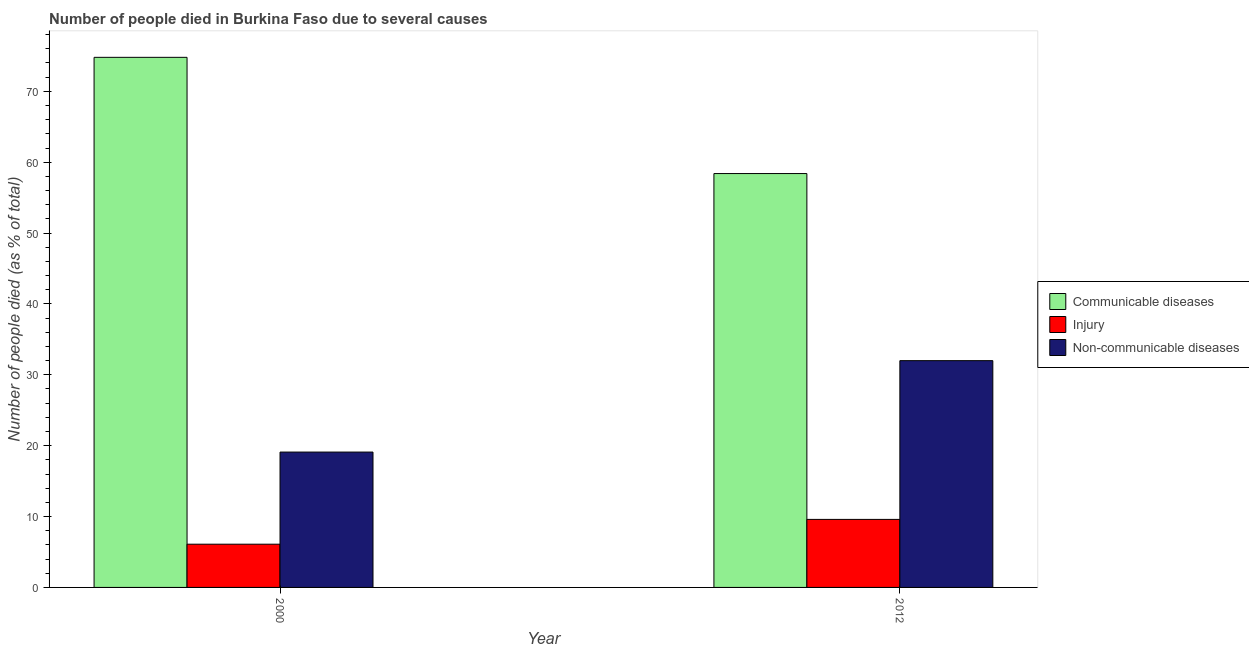Are the number of bars per tick equal to the number of legend labels?
Provide a succinct answer. Yes. Are the number of bars on each tick of the X-axis equal?
Give a very brief answer. Yes. How many bars are there on the 2nd tick from the right?
Ensure brevity in your answer.  3. What is the number of people who died of communicable diseases in 2012?
Keep it short and to the point. 58.4. Across all years, what is the minimum number of people who died of injury?
Give a very brief answer. 6.1. In which year was the number of people who died of communicable diseases maximum?
Provide a short and direct response. 2000. What is the total number of people who died of communicable diseases in the graph?
Keep it short and to the point. 133.2. What is the difference between the number of people who died of injury in 2000 and that in 2012?
Make the answer very short. -3.5. What is the average number of people who died of injury per year?
Offer a terse response. 7.85. In how many years, is the number of people who dies of non-communicable diseases greater than 2 %?
Offer a terse response. 2. What is the ratio of the number of people who dies of non-communicable diseases in 2000 to that in 2012?
Your answer should be very brief. 0.6. Is the number of people who died of communicable diseases in 2000 less than that in 2012?
Make the answer very short. No. What does the 3rd bar from the left in 2000 represents?
Keep it short and to the point. Non-communicable diseases. What does the 3rd bar from the right in 2000 represents?
Make the answer very short. Communicable diseases. Are all the bars in the graph horizontal?
Make the answer very short. No. How many years are there in the graph?
Your response must be concise. 2. Does the graph contain any zero values?
Keep it short and to the point. No. How many legend labels are there?
Provide a short and direct response. 3. How are the legend labels stacked?
Ensure brevity in your answer.  Vertical. What is the title of the graph?
Offer a very short reply. Number of people died in Burkina Faso due to several causes. What is the label or title of the X-axis?
Ensure brevity in your answer.  Year. What is the label or title of the Y-axis?
Your answer should be compact. Number of people died (as % of total). What is the Number of people died (as % of total) of Communicable diseases in 2000?
Offer a terse response. 74.8. What is the Number of people died (as % of total) in Non-communicable diseases in 2000?
Provide a succinct answer. 19.1. What is the Number of people died (as % of total) in Communicable diseases in 2012?
Offer a very short reply. 58.4. What is the Number of people died (as % of total) in Non-communicable diseases in 2012?
Offer a very short reply. 32. Across all years, what is the maximum Number of people died (as % of total) in Communicable diseases?
Give a very brief answer. 74.8. Across all years, what is the minimum Number of people died (as % of total) of Communicable diseases?
Offer a terse response. 58.4. Across all years, what is the minimum Number of people died (as % of total) of Injury?
Ensure brevity in your answer.  6.1. Across all years, what is the minimum Number of people died (as % of total) in Non-communicable diseases?
Provide a short and direct response. 19.1. What is the total Number of people died (as % of total) in Communicable diseases in the graph?
Keep it short and to the point. 133.2. What is the total Number of people died (as % of total) of Injury in the graph?
Offer a very short reply. 15.7. What is the total Number of people died (as % of total) of Non-communicable diseases in the graph?
Your answer should be very brief. 51.1. What is the difference between the Number of people died (as % of total) of Non-communicable diseases in 2000 and that in 2012?
Ensure brevity in your answer.  -12.9. What is the difference between the Number of people died (as % of total) in Communicable diseases in 2000 and the Number of people died (as % of total) in Injury in 2012?
Provide a short and direct response. 65.2. What is the difference between the Number of people died (as % of total) of Communicable diseases in 2000 and the Number of people died (as % of total) of Non-communicable diseases in 2012?
Your answer should be very brief. 42.8. What is the difference between the Number of people died (as % of total) in Injury in 2000 and the Number of people died (as % of total) in Non-communicable diseases in 2012?
Offer a very short reply. -25.9. What is the average Number of people died (as % of total) in Communicable diseases per year?
Your answer should be very brief. 66.6. What is the average Number of people died (as % of total) in Injury per year?
Make the answer very short. 7.85. What is the average Number of people died (as % of total) of Non-communicable diseases per year?
Make the answer very short. 25.55. In the year 2000, what is the difference between the Number of people died (as % of total) of Communicable diseases and Number of people died (as % of total) of Injury?
Make the answer very short. 68.7. In the year 2000, what is the difference between the Number of people died (as % of total) of Communicable diseases and Number of people died (as % of total) of Non-communicable diseases?
Offer a terse response. 55.7. In the year 2000, what is the difference between the Number of people died (as % of total) in Injury and Number of people died (as % of total) in Non-communicable diseases?
Your response must be concise. -13. In the year 2012, what is the difference between the Number of people died (as % of total) of Communicable diseases and Number of people died (as % of total) of Injury?
Your response must be concise. 48.8. In the year 2012, what is the difference between the Number of people died (as % of total) in Communicable diseases and Number of people died (as % of total) in Non-communicable diseases?
Offer a very short reply. 26.4. In the year 2012, what is the difference between the Number of people died (as % of total) of Injury and Number of people died (as % of total) of Non-communicable diseases?
Your answer should be very brief. -22.4. What is the ratio of the Number of people died (as % of total) in Communicable diseases in 2000 to that in 2012?
Your answer should be compact. 1.28. What is the ratio of the Number of people died (as % of total) of Injury in 2000 to that in 2012?
Ensure brevity in your answer.  0.64. What is the ratio of the Number of people died (as % of total) of Non-communicable diseases in 2000 to that in 2012?
Your answer should be very brief. 0.6. What is the difference between the highest and the lowest Number of people died (as % of total) in Communicable diseases?
Your response must be concise. 16.4. What is the difference between the highest and the lowest Number of people died (as % of total) in Injury?
Make the answer very short. 3.5. What is the difference between the highest and the lowest Number of people died (as % of total) of Non-communicable diseases?
Provide a short and direct response. 12.9. 